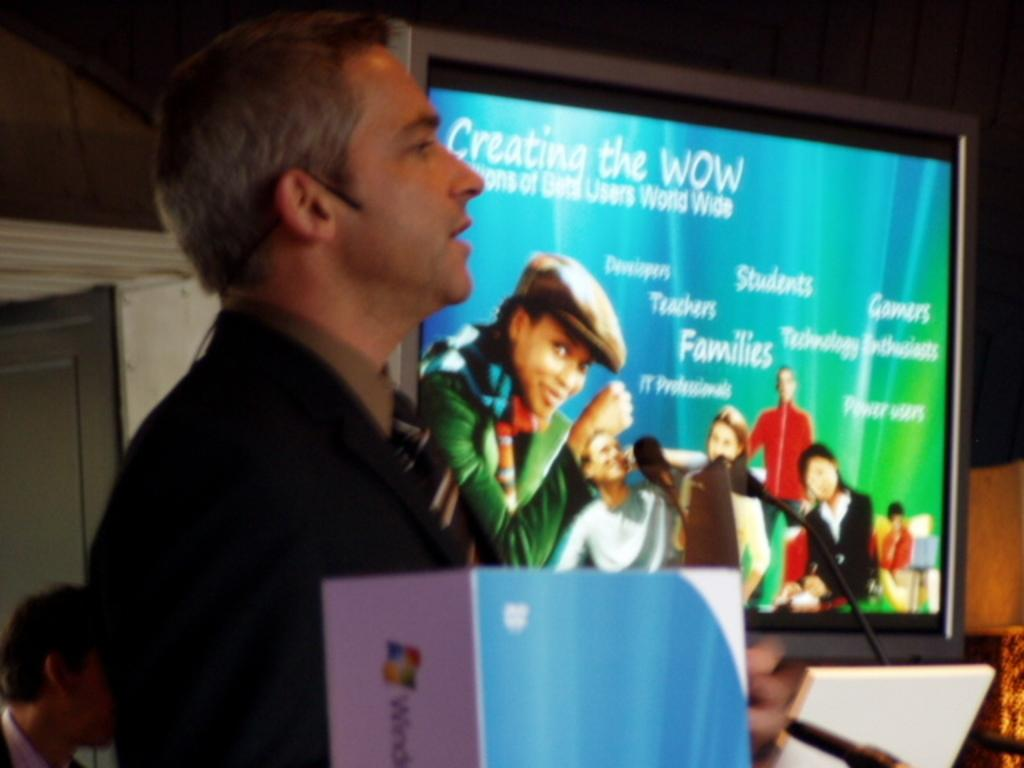Who is on the left side of the image? There is a man on the left side of the image. What is the main object in the middle of the image? There is a large television in the middle of the image. What can be seen on the television screen? People are visible on the television screen. What type of slip can be seen on the floor near the man? There is no slip present on the floor near the man in the image. How many ducks are visible on the television screen? There are no ducks visible on the television screen; people are the ones visible. 